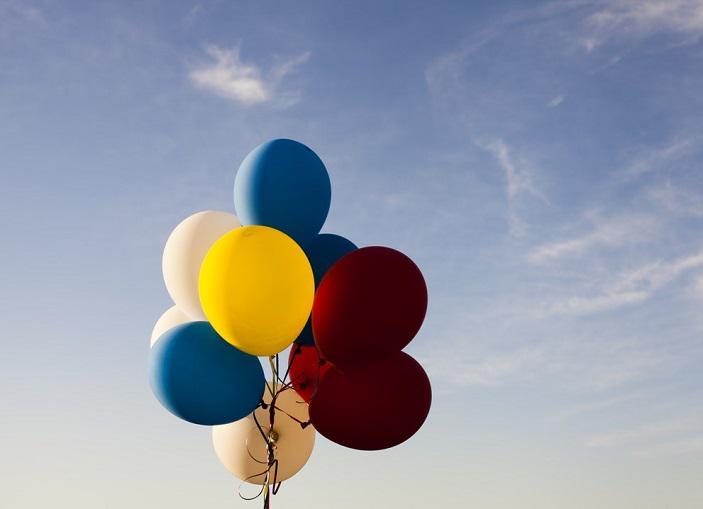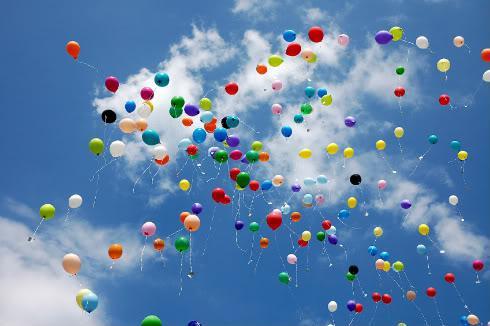The first image is the image on the left, the second image is the image on the right. Examine the images to the left and right. Is the description "The left image features a string-tied 'bunch' of no more than ten balloons, and the right image shows balloons scattered across the sky." accurate? Answer yes or no. Yes. The first image is the image on the left, the second image is the image on the right. Examine the images to the left and right. Is the description "More than 50 individual loose balloons float up into the sky." accurate? Answer yes or no. Yes. 